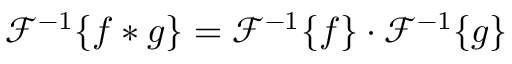<formula> <loc_0><loc_0><loc_500><loc_500>{ \mathcal { F } } ^ { - 1 } \{ f * g \} = { \mathcal { F } } ^ { - 1 } \{ f \} \cdot { \mathcal { F } } ^ { - 1 } \{ g \}</formula> 